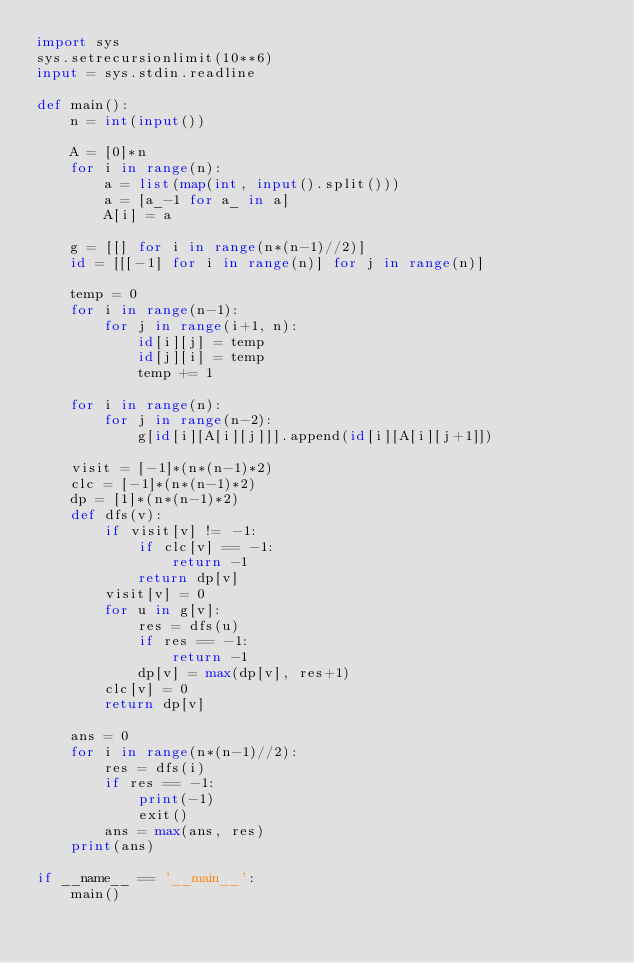Convert code to text. <code><loc_0><loc_0><loc_500><loc_500><_Python_>import sys
sys.setrecursionlimit(10**6)
input = sys.stdin.readline

def main():
    n = int(input())

    A = [0]*n
    for i in range(n):
        a = list(map(int, input().split()))
        a = [a_-1 for a_ in a]
        A[i] = a

    g = [[] for i in range(n*(n-1)//2)]
    id = [[[-1] for i in range(n)] for j in range(n)]

    temp = 0
    for i in range(n-1):
        for j in range(i+1, n):
            id[i][j] = temp
            id[j][i] = temp
            temp += 1

    for i in range(n):
        for j in range(n-2):
            g[id[i][A[i][j]]].append(id[i][A[i][j+1]])

    visit = [-1]*(n*(n-1)*2)
    clc = [-1]*(n*(n-1)*2)
    dp = [1]*(n*(n-1)*2)
    def dfs(v):
        if visit[v] != -1:
            if clc[v] == -1:
                return -1
            return dp[v]
        visit[v] = 0
        for u in g[v]:
            res = dfs(u)
            if res == -1:
                return -1
            dp[v] = max(dp[v], res+1)
        clc[v] = 0
        return dp[v]

    ans = 0
    for i in range(n*(n-1)//2):
        res = dfs(i)
        if res == -1:
            print(-1)
            exit()
        ans = max(ans, res)
    print(ans)

if __name__ == '__main__':
    main()</code> 